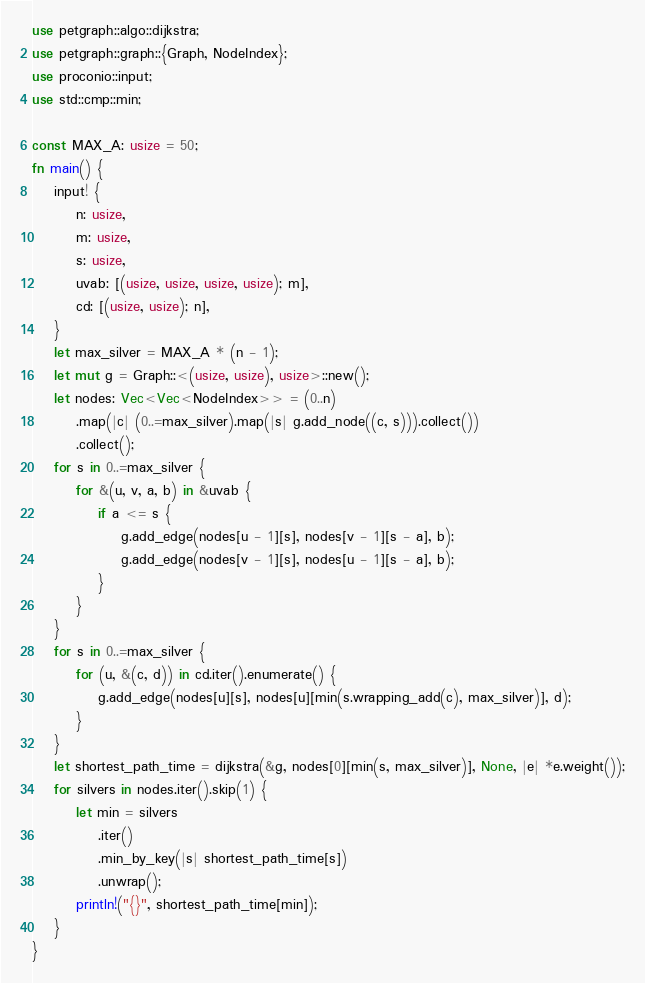<code> <loc_0><loc_0><loc_500><loc_500><_Rust_>use petgraph::algo::dijkstra;
use petgraph::graph::{Graph, NodeIndex};
use proconio::input;
use std::cmp::min;

const MAX_A: usize = 50;
fn main() {
    input! {
        n: usize,
        m: usize,
        s: usize,
        uvab: [(usize, usize, usize, usize); m],
        cd: [(usize, usize); n],
    }
    let max_silver = MAX_A * (n - 1);
    let mut g = Graph::<(usize, usize), usize>::new();
    let nodes: Vec<Vec<NodeIndex>> = (0..n)
        .map(|c| (0..=max_silver).map(|s| g.add_node((c, s))).collect())
        .collect();
    for s in 0..=max_silver {
        for &(u, v, a, b) in &uvab {
            if a <= s {
                g.add_edge(nodes[u - 1][s], nodes[v - 1][s - a], b);
                g.add_edge(nodes[v - 1][s], nodes[u - 1][s - a], b);
            }
        }
    }
    for s in 0..=max_silver {
        for (u, &(c, d)) in cd.iter().enumerate() {
            g.add_edge(nodes[u][s], nodes[u][min(s.wrapping_add(c), max_silver)], d);
        }
    }
    let shortest_path_time = dijkstra(&g, nodes[0][min(s, max_silver)], None, |e| *e.weight());
    for silvers in nodes.iter().skip(1) {
        let min = silvers
            .iter()
            .min_by_key(|s| shortest_path_time[s])
            .unwrap();
        println!("{}", shortest_path_time[min]);
    }
}
</code> 